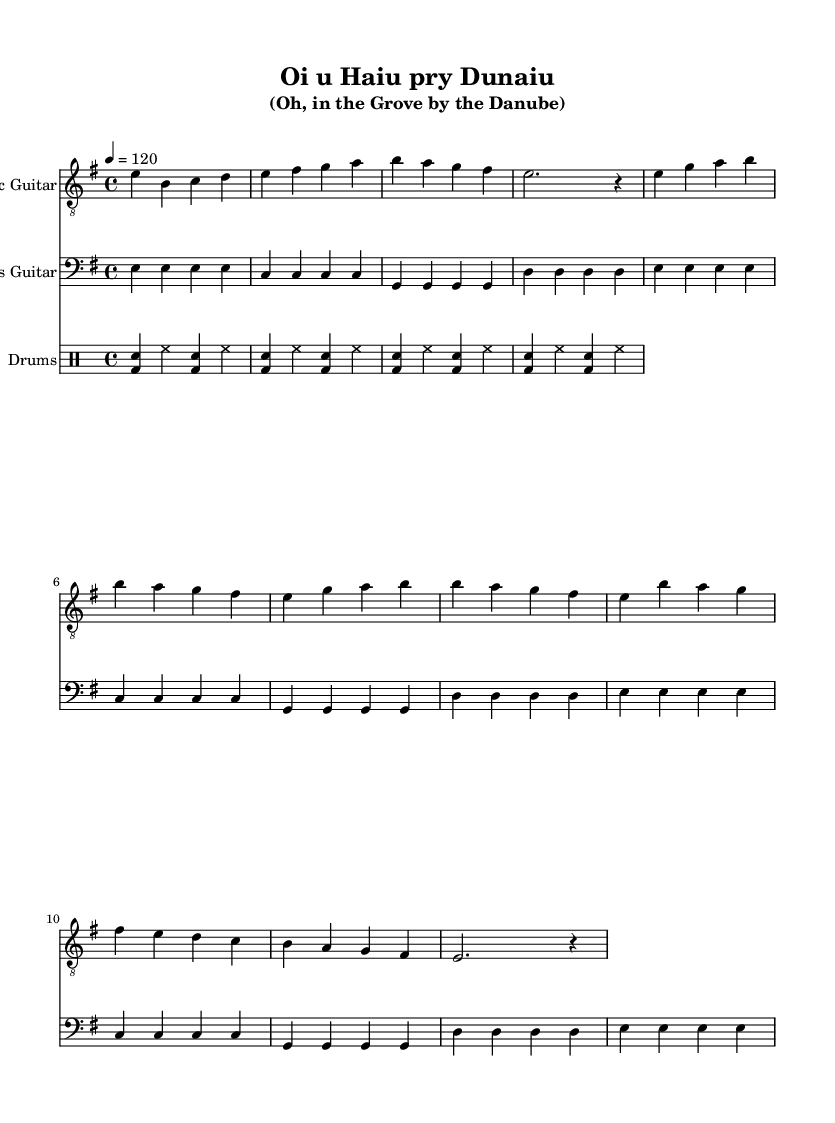What is the key signature of this music? The key signature is E minor, which has one sharp (F#). This is indicated at the beginning of the music notation.
Answer: E minor What is the time signature of this music? The time signature is 4/4, which means there are four beats in a measure and the quarter note gets one beat. This can be found at the beginning of the score.
Answer: 4/4 What tempo is indicated for this piece? The tempo marking is 120 beats per minute, meaning the quarter note is played at a speed of 120 beats every minute. This is specified in the tempo indication at the beginning of the score.
Answer: 120 How many measures are in the verse section? The verse section contains 8 measures, as counted in the score where the verse pattern is presented. Each measure is separated by a vertical line.
Answer: 8 What is the main instrument featured in this arrangement? The primary instrument featured in this arrangement is the electric guitar, which is given a clef at the start and carries the melody throughout.
Answer: Electric Guitar What is the rhythm pattern used in the drums? The rhythm pattern in the drums follows a standard rock beat consisting of bass drum and snare accents, with hi-hat cymbals on every eighth note. This typical rock pattern is recognizable in the drum notation.
Answer: Basic rock beat How does the chorus differ from the verse in terms of melody? The melody in the chorus tends to have a higher pitch range and includes different notes compared to the verse, as indicated by the different note sequences in the sheet music. This creates a contrast and highlights the chorus section.
Answer: Higher pitch 